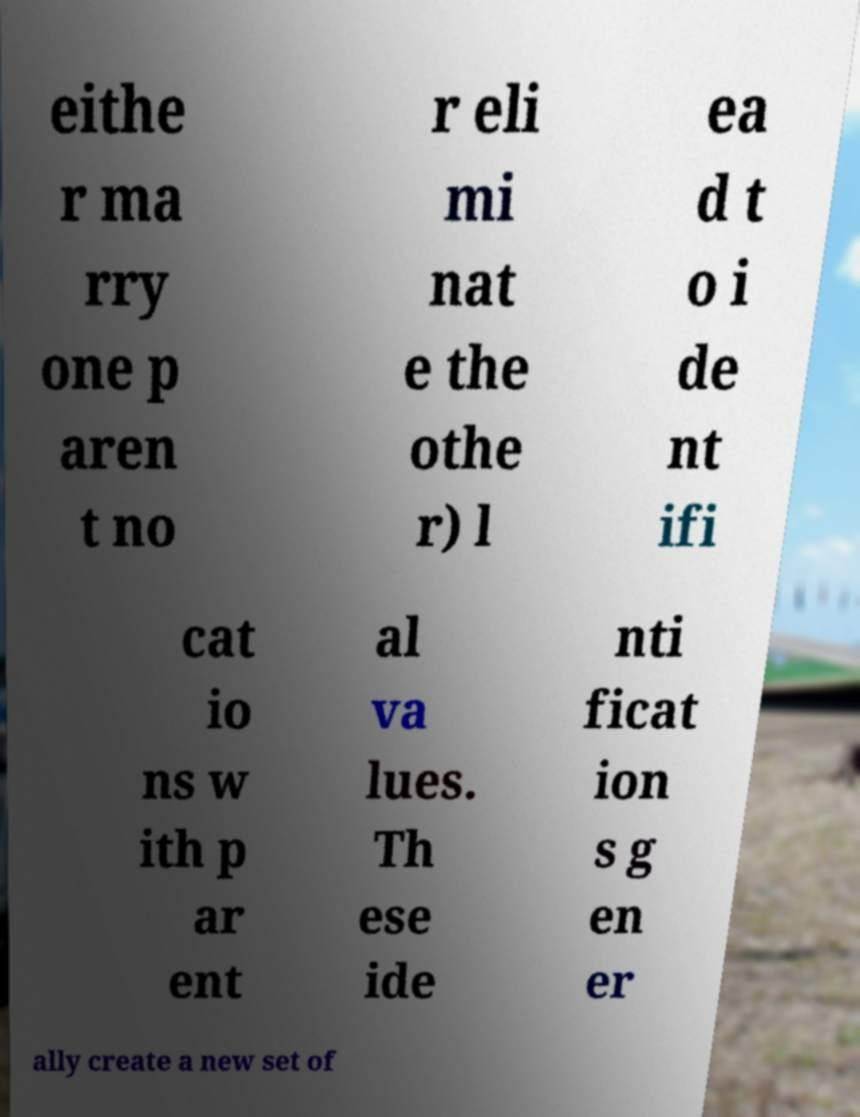I need the written content from this picture converted into text. Can you do that? eithe r ma rry one p aren t no r eli mi nat e the othe r) l ea d t o i de nt ifi cat io ns w ith p ar ent al va lues. Th ese ide nti ficat ion s g en er ally create a new set of 